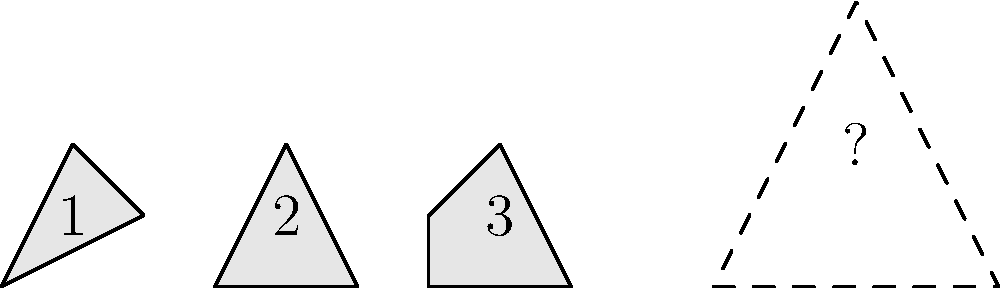Examine the three pottery fragments labeled 1, 2, and 3. If these pieces were part of a complete Eastern Wu vessel, which fragment would fit into the position indicated by the dashed outline to form a symmetrical pattern? To solve this problem, we need to follow these steps:

1. Analyze the shape and orientation of the dashed outline:
   The dashed outline forms an isosceles triangle with its base at the bottom and apex pointing upward.

2. Compare each fragment to the dashed outline:
   Fragment 1: Roughly triangular, but oriented with apex downward.
   Fragment 2: Triangular, with apex upward, similar to the dashed outline.
   Fragment 3: Quadrilateral shape, not matching the triangular outline.

3. Consider the symmetry of the complete vessel:
   Eastern Wu pottery often featured symmetrical designs. The dashed outline suggests a symmetrical pattern.

4. Mentally rotate and flip the fragments:
   Fragment 1: When flipped vertically, it closely matches the dashed outline.
   Fragment 2: Already matches the outline's orientation, but is smaller.
   Fragment 3: Cannot be rotated or flipped to match the triangular shape.

5. Evaluate the size and proportions:
   Fragment 1, when flipped, most closely matches the size and proportions of the dashed outline.

6. Consider the historical context:
   Eastern Wu pottery often featured triangular patterns and symmetrical designs, supporting the choice of a triangular fragment.

Based on these considerations, Fragment 1, when mentally flipped vertically, best fits the dashed outline and would create a symmetrical pattern typical of Eastern Wu pottery.
Answer: Fragment 1 (flipped vertically) 